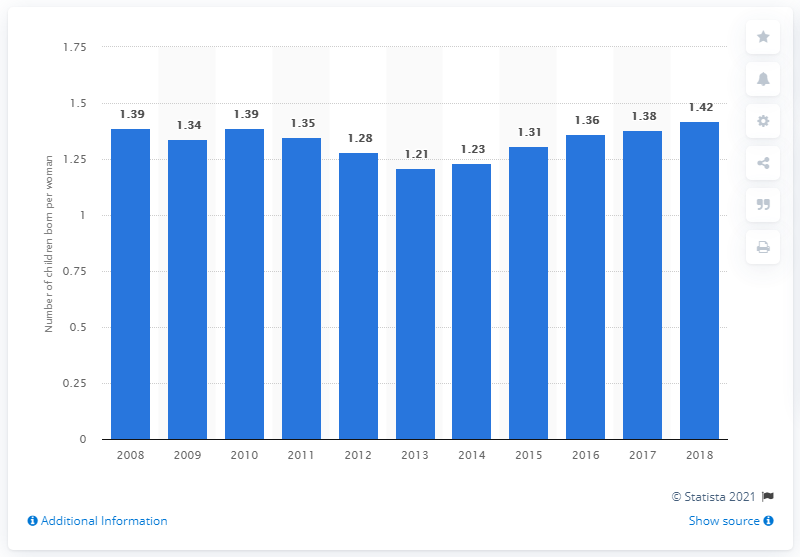What could be some socioeconomic factors influencing the changes in fertility rate over these years? Several socioeconomic factors may influence changes in fertility rates, such as economic stability, access to education and family planning, changes in societal attitudes towards family size, and parental leave policies. Economic crises can lead to lower birth rates, while periods of growth might contribute to an increase in fertility rates. Has there been any significant political or policy changes during this time that could have affected fertility rates? Yes, governments often enact family-friendly policies, such as parental leave, childcare support, and tax incentives, which can encourage higher birth rates. Changes in these policies, as well as broader political shifts that affect the economy or social welfare systems, can have a direct impact on fertility rates. 